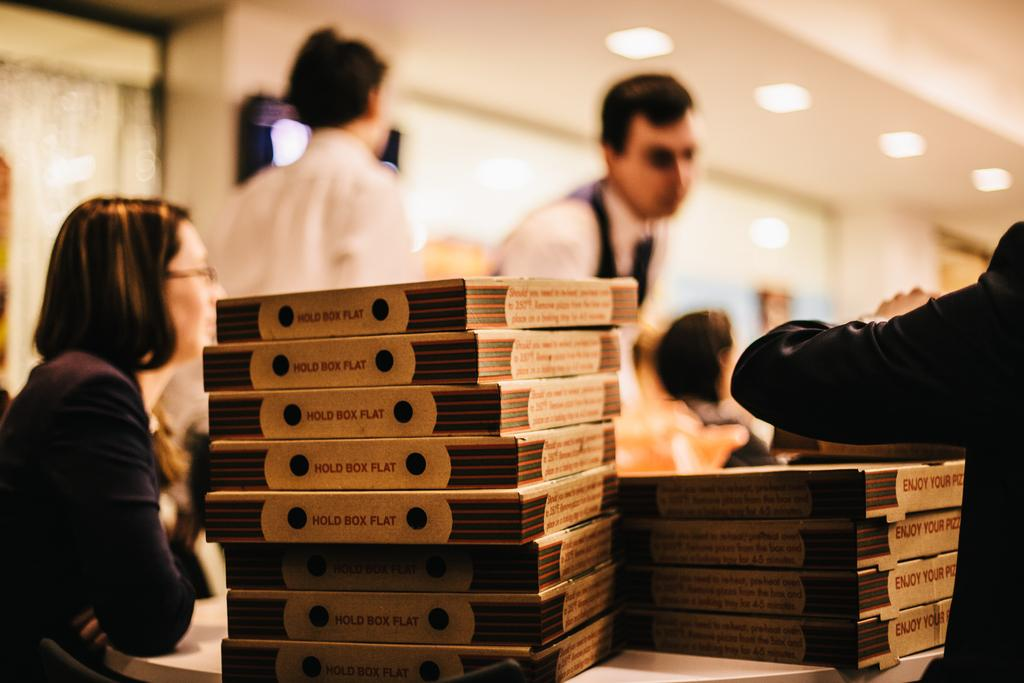What are the people in the image doing? The people in the image are standing. Is there anyone sitting in the image? Yes, there is a person sitting in the image. What objects can be seen on the table in the image? There are books on a table in the image. Can you describe the background of the image? The background of the image is blurred. What type of tomatoes can be seen in the image? There are no tomatoes present in the image. 